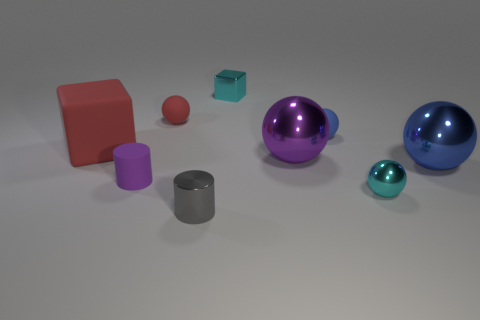How many other objects are there of the same size as the purple shiny object?
Ensure brevity in your answer.  2. There is a red thing that is on the right side of the red object that is in front of the tiny blue sphere that is right of the red matte cube; what shape is it?
Your response must be concise. Sphere. There is a red sphere; is its size the same as the cyan object behind the tiny purple cylinder?
Your answer should be very brief. Yes. There is a object that is in front of the big rubber block and behind the blue shiny object; what color is it?
Keep it short and to the point. Purple. What number of other objects are there of the same shape as the tiny blue object?
Offer a very short reply. 4. Do the cylinder that is to the right of the tiny red sphere and the matte ball that is on the right side of the cyan metallic cube have the same color?
Ensure brevity in your answer.  No. Is the size of the purple object that is left of the small metallic cylinder the same as the blue thing in front of the large purple metal ball?
Provide a short and direct response. No. Is there anything else that is the same material as the big red block?
Offer a very short reply. Yes. What material is the small cyan thing that is in front of the small rubber thing left of the sphere that is left of the tiny cyan metallic block?
Keep it short and to the point. Metal. Do the gray shiny thing and the tiny purple object have the same shape?
Keep it short and to the point. Yes. 